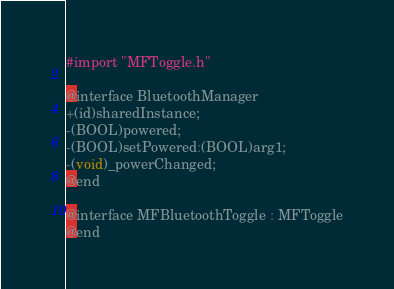<code> <loc_0><loc_0><loc_500><loc_500><_C_>#import "MFToggle.h"

@interface BluetoothManager
+(id)sharedInstance;
-(BOOL)powered;
-(BOOL)setPowered:(BOOL)arg1;
-(void)_powerChanged;
@end

@interface MFBluetoothToggle : MFToggle
@end</code> 